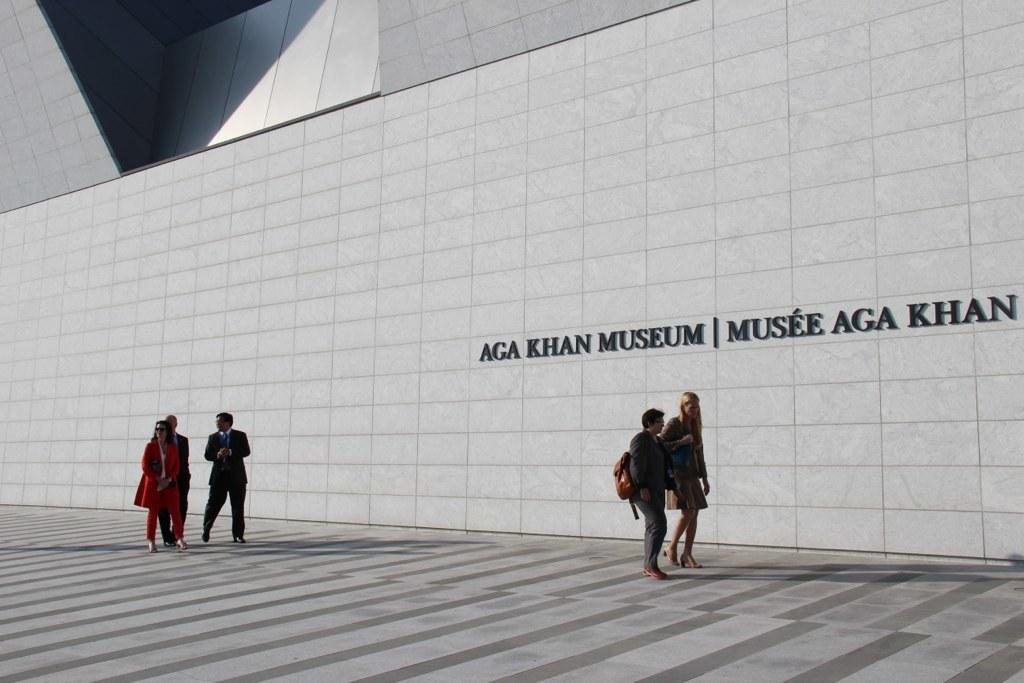What is written on the wall in the image? There is a wall with the name of the museum in the image. What are the people in the image doing? There are people walking on a path in the image. Where is the print shop located in the image? There is no print shop present in the image. What type of bag is being carried by the people in the image? The image does not show any bags being carried by the people. 